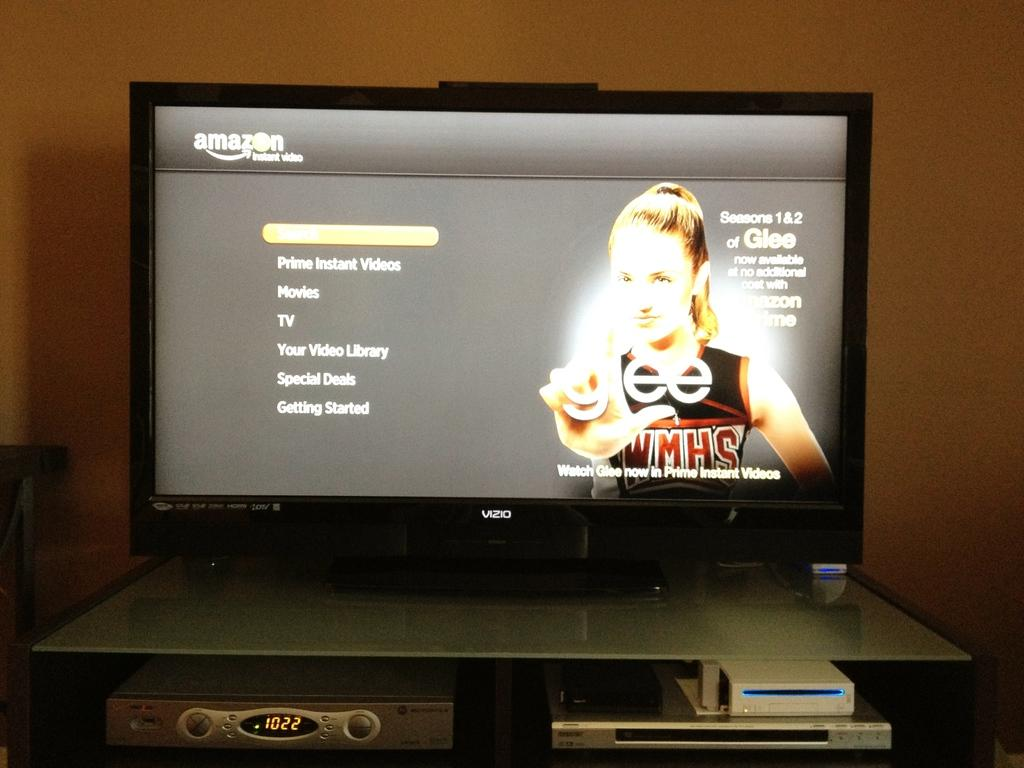<image>
Give a short and clear explanation of the subsequent image. The show Glee on a TV with options to watch it 